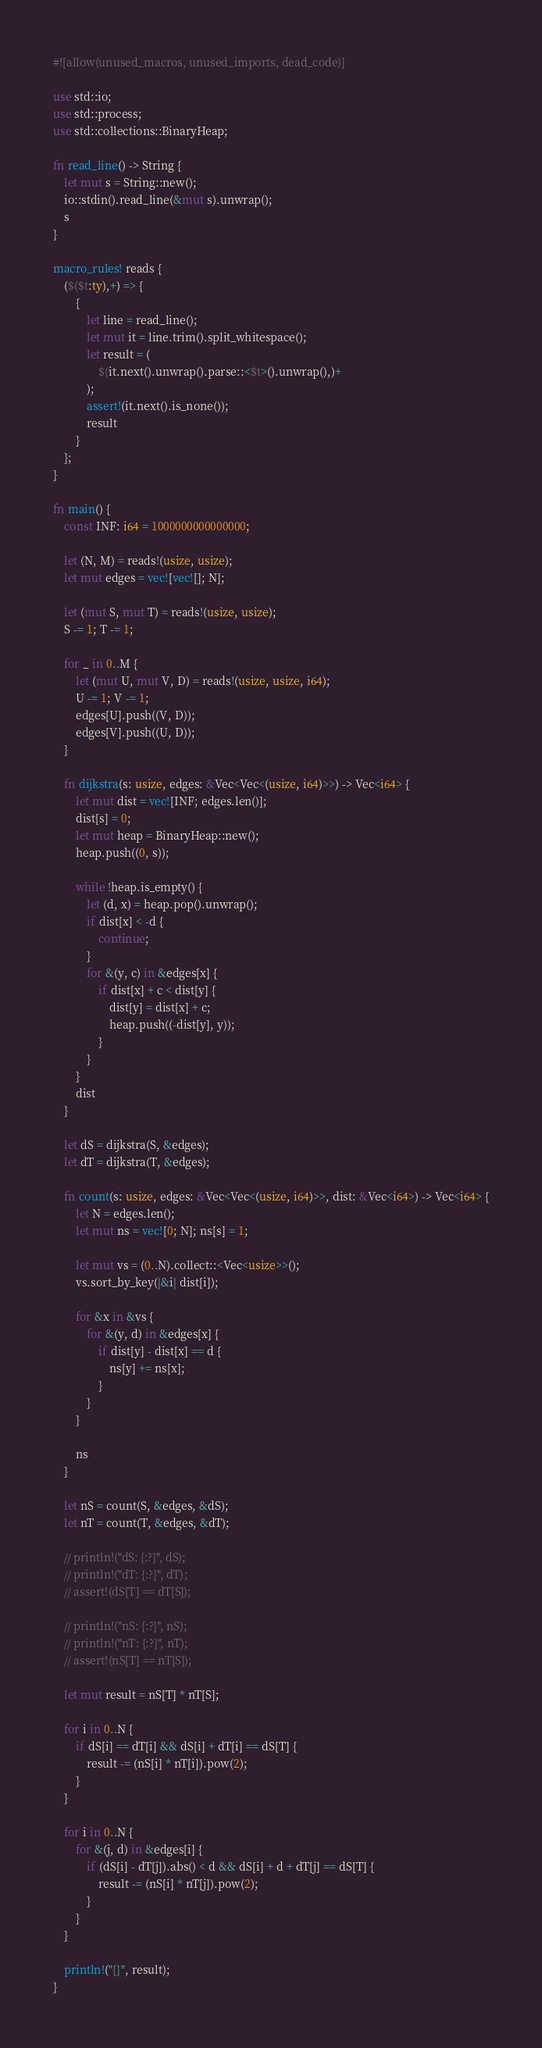<code> <loc_0><loc_0><loc_500><loc_500><_Rust_>#![allow(unused_macros, unused_imports, dead_code)]

use std::io;
use std::process;
use std::collections::BinaryHeap;

fn read_line() -> String {
    let mut s = String::new();
    io::stdin().read_line(&mut s).unwrap();
    s
}

macro_rules! reads {
    ($($t:ty),+) => {
        {
            let line = read_line();
            let mut it = line.trim().split_whitespace();
            let result = (
                $(it.next().unwrap().parse::<$t>().unwrap(),)+
            );
            assert!(it.next().is_none());
            result
        }
    };
}

fn main() {
    const INF: i64 = 1000000000000000;

    let (N, M) = reads!(usize, usize);
    let mut edges = vec![vec![]; N];

    let (mut S, mut T) = reads!(usize, usize);
    S -= 1; T -= 1;

    for _ in 0..M {
        let (mut U, mut V, D) = reads!(usize, usize, i64);
        U -= 1; V -= 1;
        edges[U].push((V, D));
        edges[V].push((U, D));
    }

    fn dijkstra(s: usize, edges: &Vec<Vec<(usize, i64)>>) -> Vec<i64> {
        let mut dist = vec![INF; edges.len()];
        dist[s] = 0;
        let mut heap = BinaryHeap::new();
        heap.push((0, s));

        while !heap.is_empty() {
            let (d, x) = heap.pop().unwrap();
            if dist[x] < -d {
                continue;
            }
            for &(y, c) in &edges[x] {
                if dist[x] + c < dist[y] {
                    dist[y] = dist[x] + c;
                    heap.push((-dist[y], y));
                }
            }
        }
        dist
    }

    let dS = dijkstra(S, &edges);
    let dT = dijkstra(T, &edges);

    fn count(s: usize, edges: &Vec<Vec<(usize, i64)>>, dist: &Vec<i64>) -> Vec<i64> {
        let N = edges.len();
        let mut ns = vec![0; N]; ns[s] = 1;

        let mut vs = (0..N).collect::<Vec<usize>>();
        vs.sort_by_key(|&i| dist[i]);

        for &x in &vs {
            for &(y, d) in &edges[x] {
                if dist[y] - dist[x] == d {
                    ns[y] += ns[x];
                }
            }
        }

        ns
    }

    let nS = count(S, &edges, &dS);
    let nT = count(T, &edges, &dT);

    // println!("dS: {:?}", dS);
    // println!("dT: {:?}", dT);
    // assert!(dS[T] == dT[S]);

    // println!("nS: {:?}", nS);
    // println!("nT: {:?}", nT);
    // assert!(nS[T] == nT[S]);

    let mut result = nS[T] * nT[S];

    for i in 0..N {
        if dS[i] == dT[i] && dS[i] + dT[i] == dS[T] {
            result -= (nS[i] * nT[i]).pow(2);
        }
    }

    for i in 0..N {
        for &(j, d) in &edges[i] {
            if (dS[i] - dT[j]).abs() < d && dS[i] + d + dT[j] == dS[T] {
                result -= (nS[i] * nT[j]).pow(2);            
            }
        }
    }

    println!("{}", result);
}</code> 